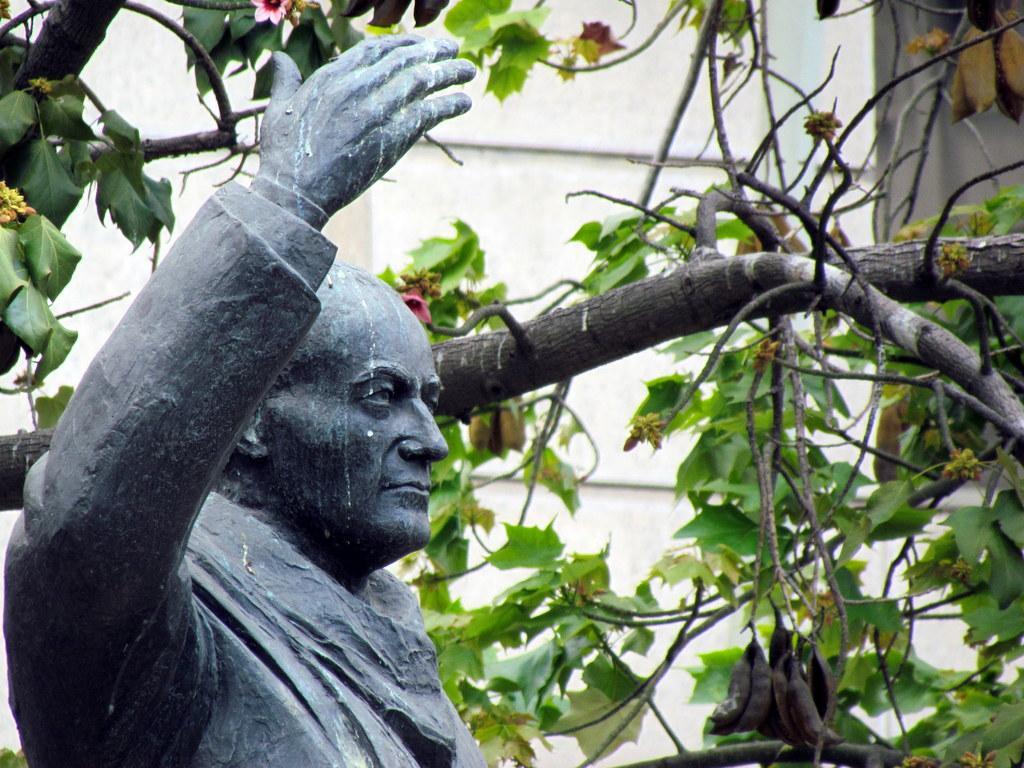Could you give a brief overview of what you see in this image? In the foreground of this image, there is a man's sculpture. Behind him, there is a tree with few flowers and in the background, there is the wall. 